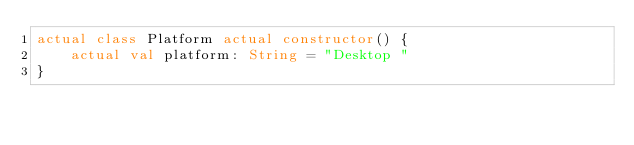<code> <loc_0><loc_0><loc_500><loc_500><_Kotlin_>actual class Platform actual constructor() {
    actual val platform: String = "Desktop "
}
</code> 